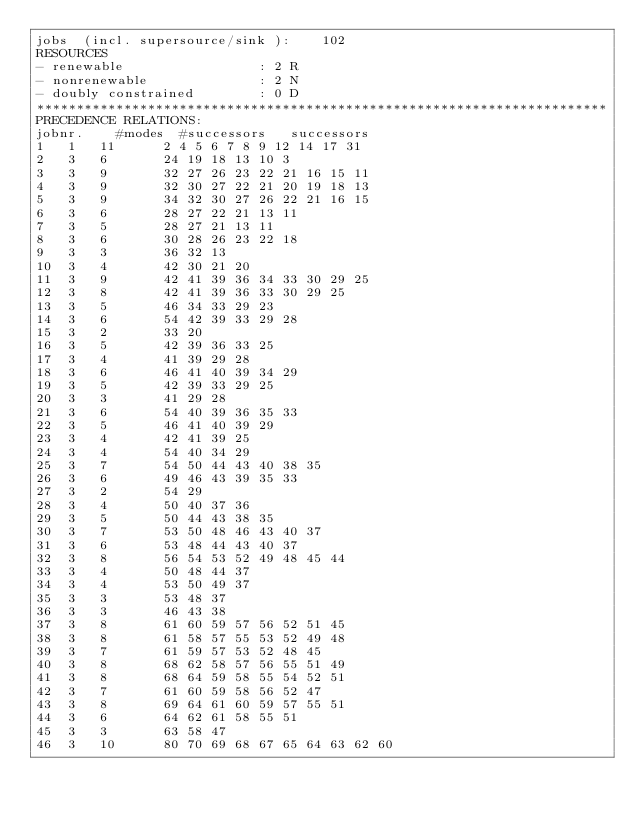<code> <loc_0><loc_0><loc_500><loc_500><_ObjectiveC_>jobs  (incl. supersource/sink ):	102
RESOURCES
- renewable                 : 2 R
- nonrenewable              : 2 N
- doubly constrained        : 0 D
************************************************************************
PRECEDENCE RELATIONS:
jobnr.    #modes  #successors   successors
1	1	11		2 4 5 6 7 8 9 12 14 17 31 
2	3	6		24 19 18 13 10 3 
3	3	9		32 27 26 23 22 21 16 15 11 
4	3	9		32 30 27 22 21 20 19 18 13 
5	3	9		34 32 30 27 26 22 21 16 15 
6	3	6		28 27 22 21 13 11 
7	3	5		28 27 21 13 11 
8	3	6		30 28 26 23 22 18 
9	3	3		36 32 13 
10	3	4		42 30 21 20 
11	3	9		42 41 39 36 34 33 30 29 25 
12	3	8		42 41 39 36 33 30 29 25 
13	3	5		46 34 33 29 23 
14	3	6		54 42 39 33 29 28 
15	3	2		33 20 
16	3	5		42 39 36 33 25 
17	3	4		41 39 29 28 
18	3	6		46 41 40 39 34 29 
19	3	5		42 39 33 29 25 
20	3	3		41 29 28 
21	3	6		54 40 39 36 35 33 
22	3	5		46 41 40 39 29 
23	3	4		42 41 39 25 
24	3	4		54 40 34 29 
25	3	7		54 50 44 43 40 38 35 
26	3	6		49 46 43 39 35 33 
27	3	2		54 29 
28	3	4		50 40 37 36 
29	3	5		50 44 43 38 35 
30	3	7		53 50 48 46 43 40 37 
31	3	6		53 48 44 43 40 37 
32	3	8		56 54 53 52 49 48 45 44 
33	3	4		50 48 44 37 
34	3	4		53 50 49 37 
35	3	3		53 48 37 
36	3	3		46 43 38 
37	3	8		61 60 59 57 56 52 51 45 
38	3	8		61 58 57 55 53 52 49 48 
39	3	7		61 59 57 53 52 48 45 
40	3	8		68 62 58 57 56 55 51 49 
41	3	8		68 64 59 58 55 54 52 51 
42	3	7		61 60 59 58 56 52 47 
43	3	8		69 64 61 60 59 57 55 51 
44	3	6		64 62 61 58 55 51 
45	3	3		63 58 47 
46	3	10		80 70 69 68 67 65 64 63 62 60 </code> 